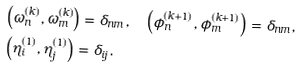<formula> <loc_0><loc_0><loc_500><loc_500>& \left ( \omega ^ { ( k ) } _ { n } , \omega ^ { ( k ) } _ { m } \right ) = \delta _ { n m } , \quad \left ( \phi ^ { ( k + 1 ) } _ { n } , \phi ^ { ( k + 1 ) } _ { m } \right ) = \delta _ { n m } , \\ & \left ( \eta ^ { ( 1 ) } _ { i } , \eta ^ { ( 1 ) } _ { j } \right ) = \delta _ { i j } .</formula> 